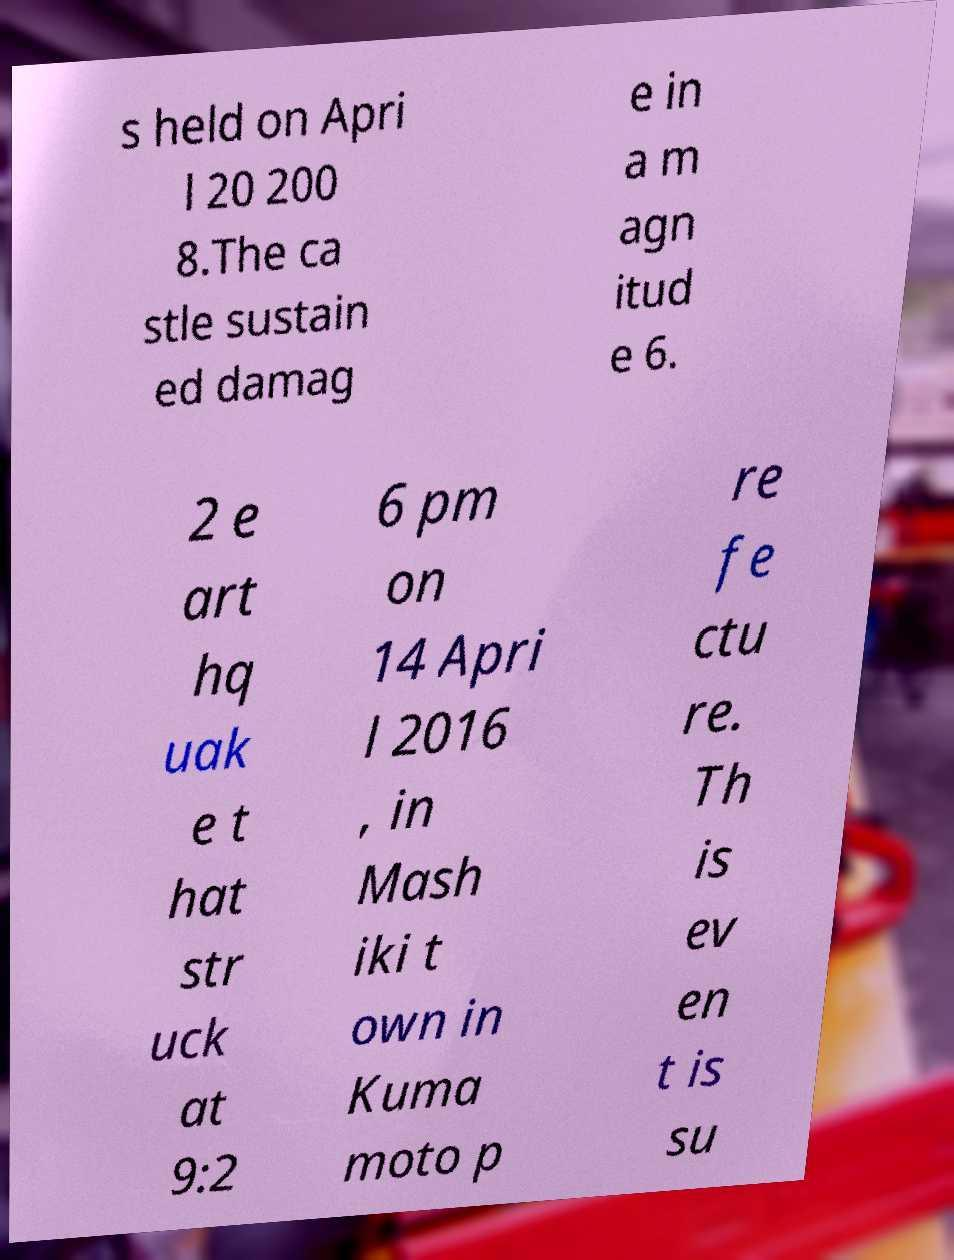For documentation purposes, I need the text within this image transcribed. Could you provide that? s held on Apri l 20 200 8.The ca stle sustain ed damag e in a m agn itud e 6. 2 e art hq uak e t hat str uck at 9:2 6 pm on 14 Apri l 2016 , in Mash iki t own in Kuma moto p re fe ctu re. Th is ev en t is su 